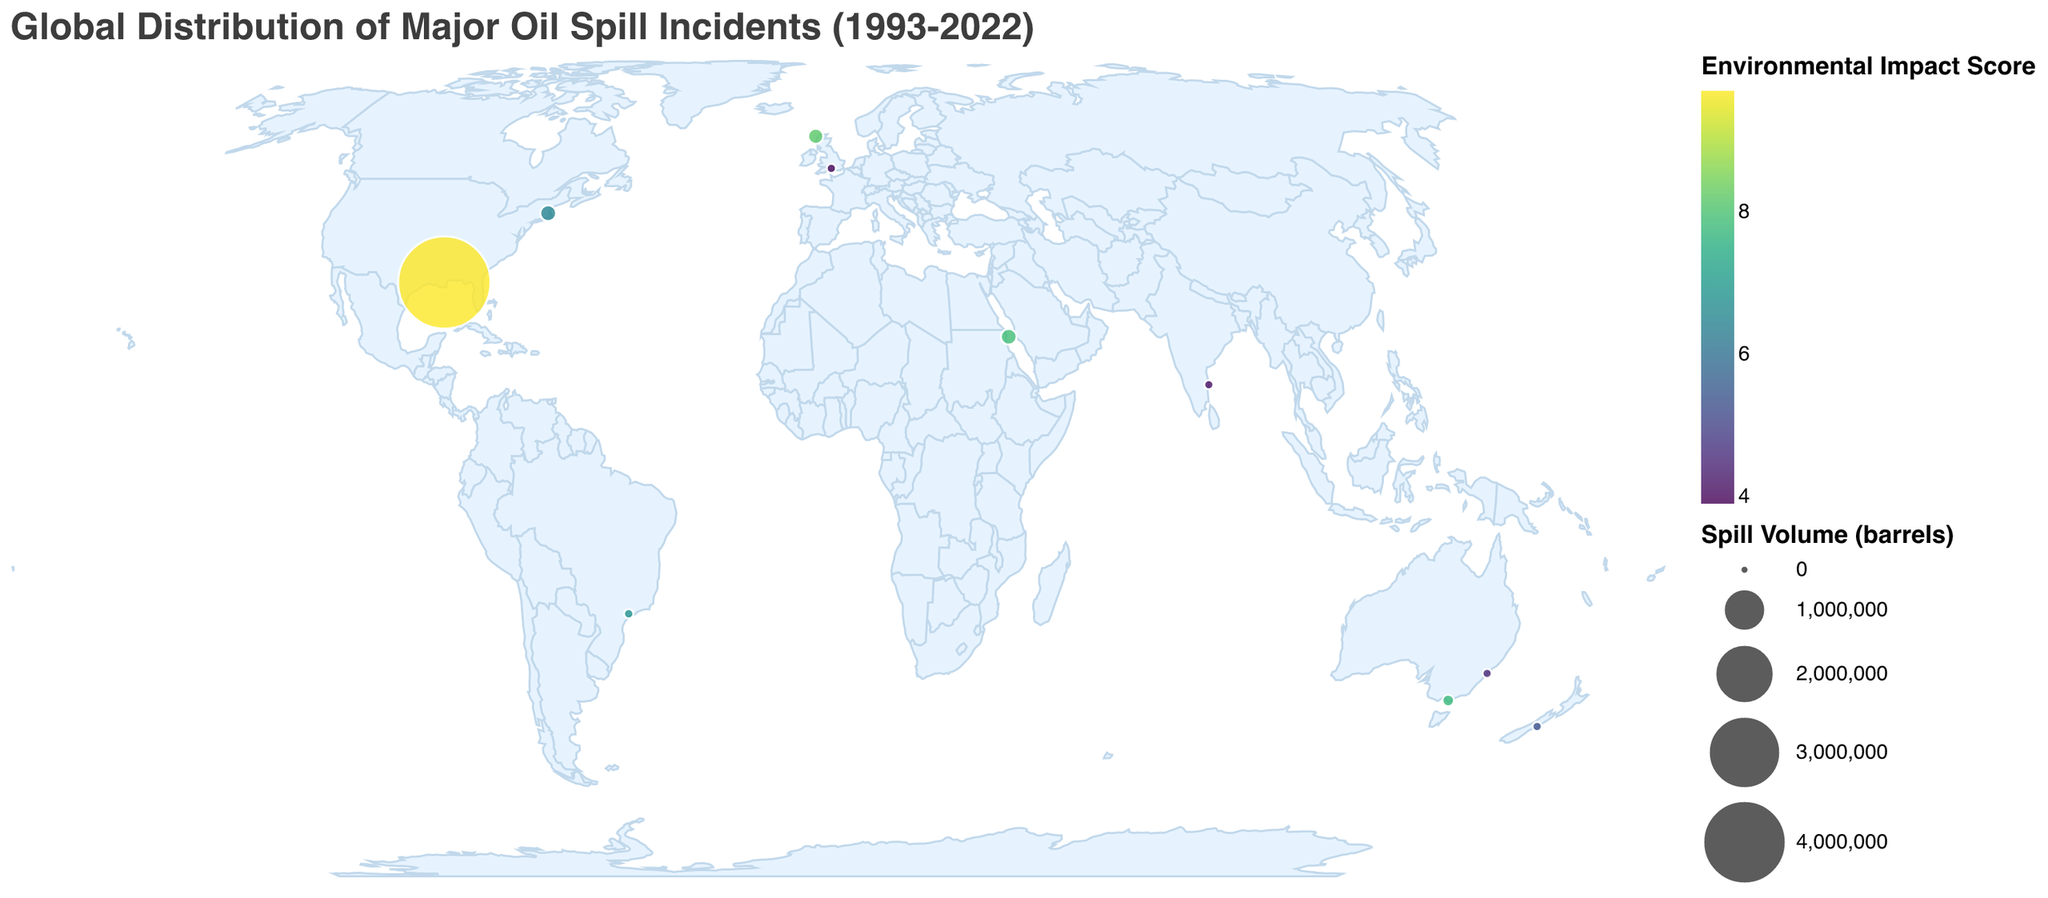What's the title of the plot? The plot title is usually shown above the plot in a larger or bold font to indicate the subject or purpose. Here, the title is directly visible at the top.
Answer: "Global Distribution of Major Oil Spill Incidents (1993-2022)" How many oil spill incidents are visualized on the map? Each oil spill incident is represented by a circular mark on the map. By counting all the circles, we can determine the number of incidents.
Answer: 10 Which oil spill incident had the largest volume of spill? The incident with the largest volume of spill can be identified by the size of the circles on the map. The largest circle represents the incident with the highest spill volume. Additionally, the tooltip will show the exact value when hovering over the circles.
Answer: Deepwater Horizon Oil Spill Which incident has the highest Environmental Impact Score? The color intensity of the circles represents the Environmental Impact Score. By comparing the colors or using the tooltip function to check the exact values, we can find the one with the highest score.
Answer: Deepwater Horizon Oil Spill What's the geographical distribution of oil spills with high Environmental Impact Scores? By observing circles with darker colors (indicating higher Environmental Impact Scores), we can identify their geographic locations on the map. These are primarily located in the Gulf of Mexico (Deepwater Horizon) and near the Shetland Islands (Braer Oil Spill).
Answer: Gulf of Mexico and Shetland Islands What is the average Environmental Impact Score of the incidents listed? The Environmental Impact Score for each incident is provided. By summing these scores and dividing by the number of incidents, we can calculate the average score. (8.2 + 7.9 + 6.5 + 7.8 + 9.7 + 5.3 + 4.1 + 6.8 + 3.9 + 4.5) / 10 = 6.47
Answer: 6.47 Compare the Spill Volume between the Sydney Harbour Oil Spill and the Chennai Oil Spill. Which one was larger? By examining the sizes of the circles representing these incidents or using the tooltip, we can see their exact Spill Volumes and compare them.
Answer: Sydney Harbour Oil Spill (500 barrels) > Chennai Oil Spill (196 barrels) How many oil spills had an Environmental Impact Score greater than 7? By looking at the colors and using tooltips, we can count the number of incidents with an Environmental Impact Score greater than 7.
Answer: 4 How many incidents occurred after the year 2000? We can check each incident's year and count how many of them are from 2001 onwards.
Answer: 7 